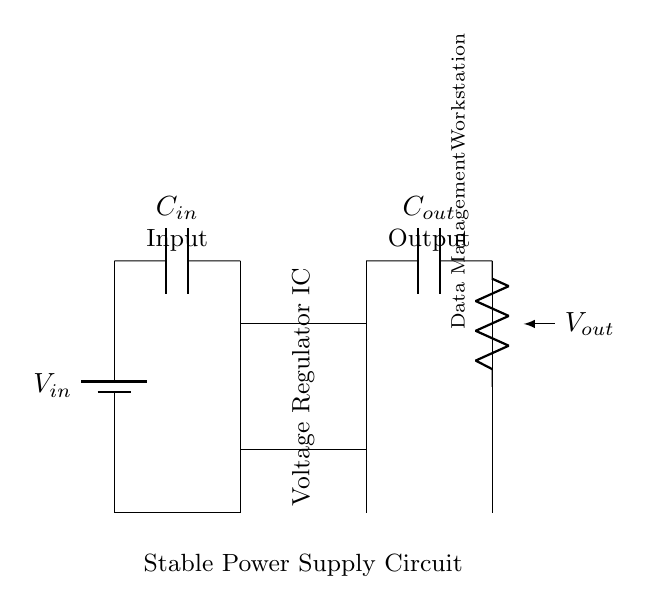What is the input component in this circuit? The input component is labeled as C in the circuit diagram and is connected to a battery, indicating that it serves as a capacitor for filtering the input voltage.
Answer: Input capacitor What does the rectangle represent in this circuit? The rectangle is a symbol for a voltage regulator integrated circuit, which regulates the output voltage to a stable level suitable for the load.
Answer: Voltage Regulator IC What is the purpose of the output capacitor? The output capacitor smooths the output voltage after it has been regulated, helping to maintain stability by filtering any high-frequency noise at the output.
Answer: Output capacitor What type of load is connected to the output of the regulator? The load connected at the output is labeled as the Data Management Workstation, which indicates that this is the device powered by the regulated output voltage.
Answer: Data Management Workstation How many components are used for voltage regulation in this circuit? Two main capacitors are used: one for the input and one for the output, alongside the voltage regulator, totaling three components involved directly in voltage regulation.
Answer: Three components What is the function of the ground connections in this circuit? Ground connections provide a common reference point for the circuit, allowing for current to return properly and establishing a stable operating voltage for the components.
Answer: Common reference point What does V out signify in this diagram? V out signifies the output voltage provided to the load, which should be stable and regulated by the voltage regulator to ensure proper functioning of the connected workstation.
Answer: Output voltage 